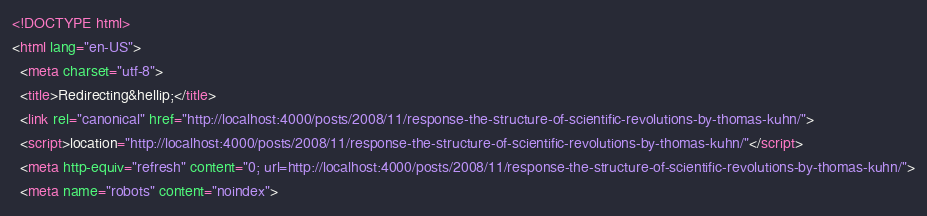Convert code to text. <code><loc_0><loc_0><loc_500><loc_500><_HTML_><!DOCTYPE html>
<html lang="en-US">
  <meta charset="utf-8">
  <title>Redirecting&hellip;</title>
  <link rel="canonical" href="http://localhost:4000/posts/2008/11/response-the-structure-of-scientific-revolutions-by-thomas-kuhn/">
  <script>location="http://localhost:4000/posts/2008/11/response-the-structure-of-scientific-revolutions-by-thomas-kuhn/"</script>
  <meta http-equiv="refresh" content="0; url=http://localhost:4000/posts/2008/11/response-the-structure-of-scientific-revolutions-by-thomas-kuhn/">
  <meta name="robots" content="noindex"></code> 